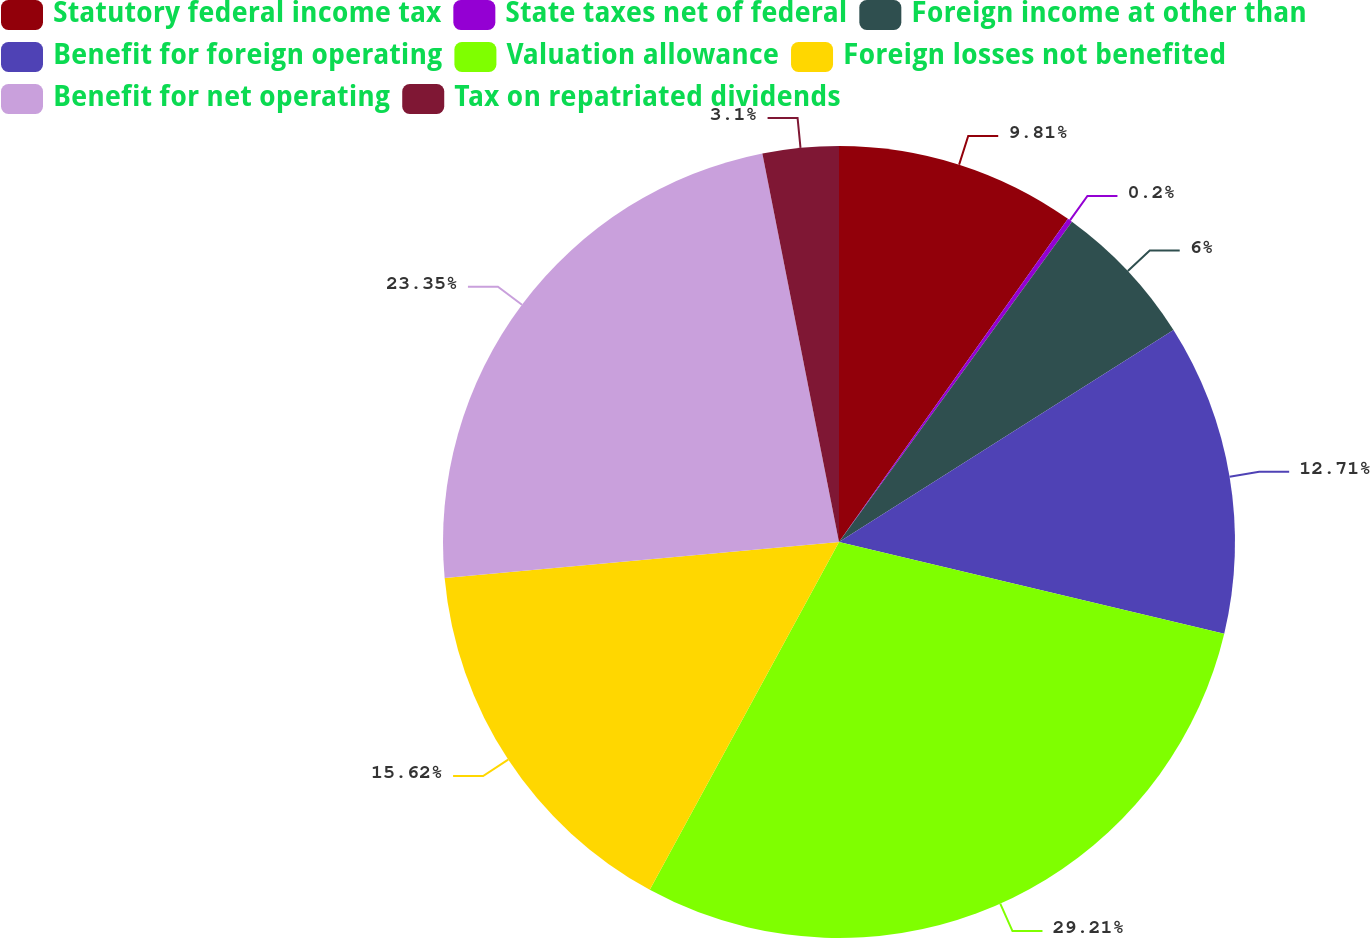Convert chart to OTSL. <chart><loc_0><loc_0><loc_500><loc_500><pie_chart><fcel>Statutory federal income tax<fcel>State taxes net of federal<fcel>Foreign income at other than<fcel>Benefit for foreign operating<fcel>Valuation allowance<fcel>Foreign losses not benefited<fcel>Benefit for net operating<fcel>Tax on repatriated dividends<nl><fcel>9.81%<fcel>0.2%<fcel>6.0%<fcel>12.71%<fcel>29.21%<fcel>15.62%<fcel>23.35%<fcel>3.1%<nl></chart> 